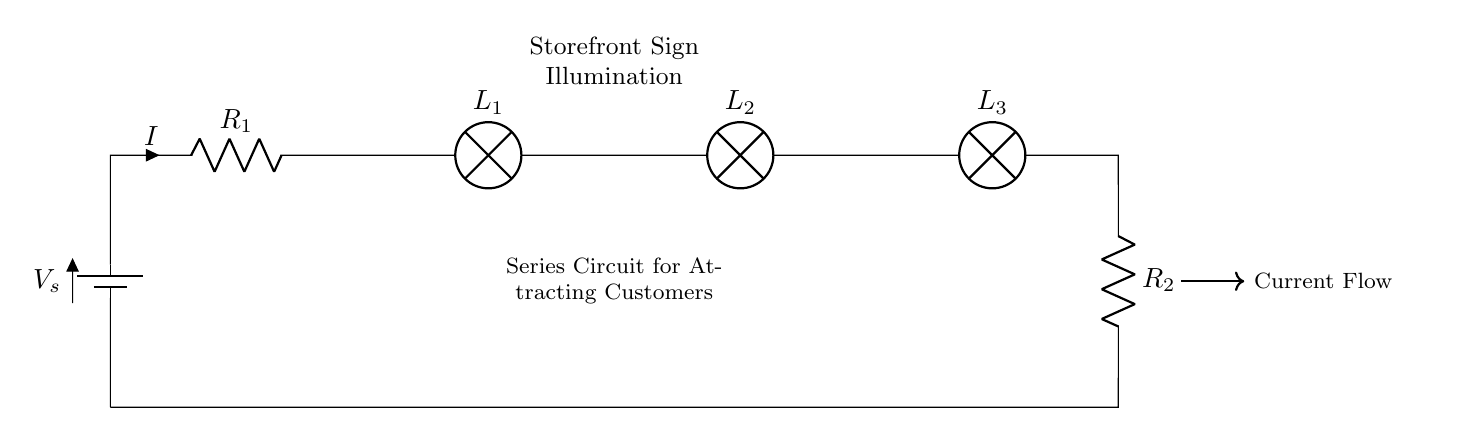What is the total voltage in this circuit? The total voltage is denoted by V_s, which represents the source voltage powering the series circuit.
Answer: V_s How many lamps are connected in this circuit? There are three lamps, labeled as L_1, L_2, and L_3, showing their inclusion in the series circuit.
Answer: 3 What is the direction of current flow in this circuit? The current flows from the battery (V_s), through the resistors and lamps, and returns to the battery, indicated by the directional arrow labeled 'Current Flow'.
Answer: Forward Which components are considered resistors in this circuit? The resistors are R_1 and R_2, indicated by their labels in the circuit diagram.
Answer: R_1 and R_2 What happens to the total resistance when more lamps are added in series? In a series circuit, the total resistance increases as more components are added, since it is the sum of all individual resistances.
Answer: Total resistance increases How does current change when resistors are added in series? In a series circuit, adding more resistors increases the total resistance, which subsequently decreases the overall current following Ohm's Law, as current is inversely proportional to resistance.
Answer: Current decreases What will happen if one lamp fails in this circuit? If one lamp fails, it will break the series circuit, causing all lamps to turn off since current cannot flow through an incomplete circuit.
Answer: All lamps turn off 